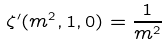<formula> <loc_0><loc_0><loc_500><loc_500>\zeta ^ { \prime } ( m ^ { 2 } , 1 , 0 ) = \frac { 1 } { m ^ { 2 } }</formula> 